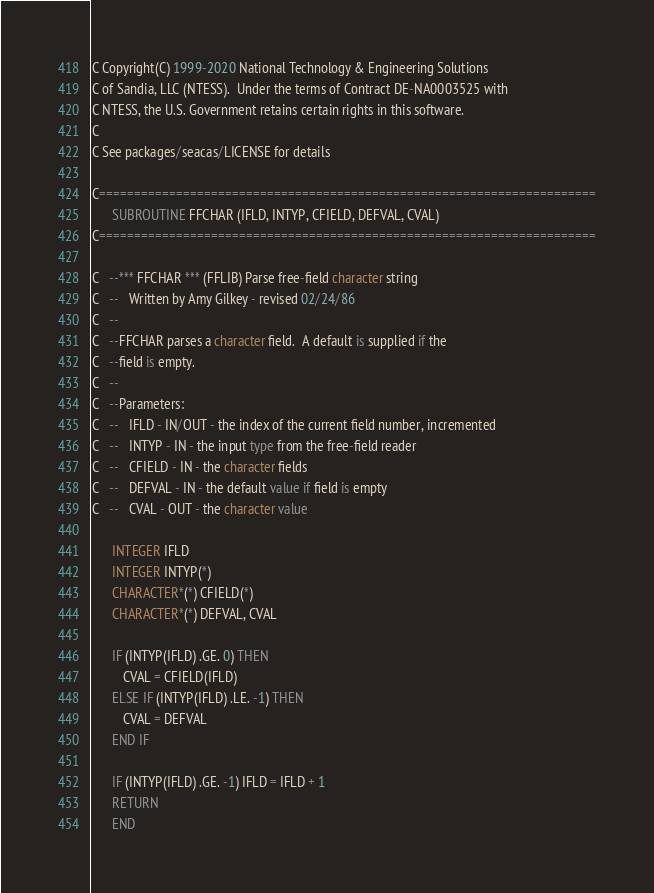Convert code to text. <code><loc_0><loc_0><loc_500><loc_500><_FORTRAN_>C Copyright(C) 1999-2020 National Technology & Engineering Solutions
C of Sandia, LLC (NTESS).  Under the terms of Contract DE-NA0003525 with
C NTESS, the U.S. Government retains certain rights in this software.
C
C See packages/seacas/LICENSE for details

C=======================================================================
      SUBROUTINE FFCHAR (IFLD, INTYP, CFIELD, DEFVAL, CVAL)
C=======================================================================

C   --*** FFCHAR *** (FFLIB) Parse free-field character string
C   --   Written by Amy Gilkey - revised 02/24/86
C   --
C   --FFCHAR parses a character field.  A default is supplied if the
C   --field is empty.
C   --
C   --Parameters:
C   --   IFLD - IN/OUT - the index of the current field number, incremented
C   --   INTYP - IN - the input type from the free-field reader
C   --   CFIELD - IN - the character fields
C   --   DEFVAL - IN - the default value if field is empty
C   --   CVAL - OUT - the character value

      INTEGER IFLD
      INTEGER INTYP(*)
      CHARACTER*(*) CFIELD(*)
      CHARACTER*(*) DEFVAL, CVAL

      IF (INTYP(IFLD) .GE. 0) THEN
         CVAL = CFIELD(IFLD)
      ELSE IF (INTYP(IFLD) .LE. -1) THEN
         CVAL = DEFVAL
      END IF

      IF (INTYP(IFLD) .GE. -1) IFLD = IFLD + 1
      RETURN
      END
</code> 